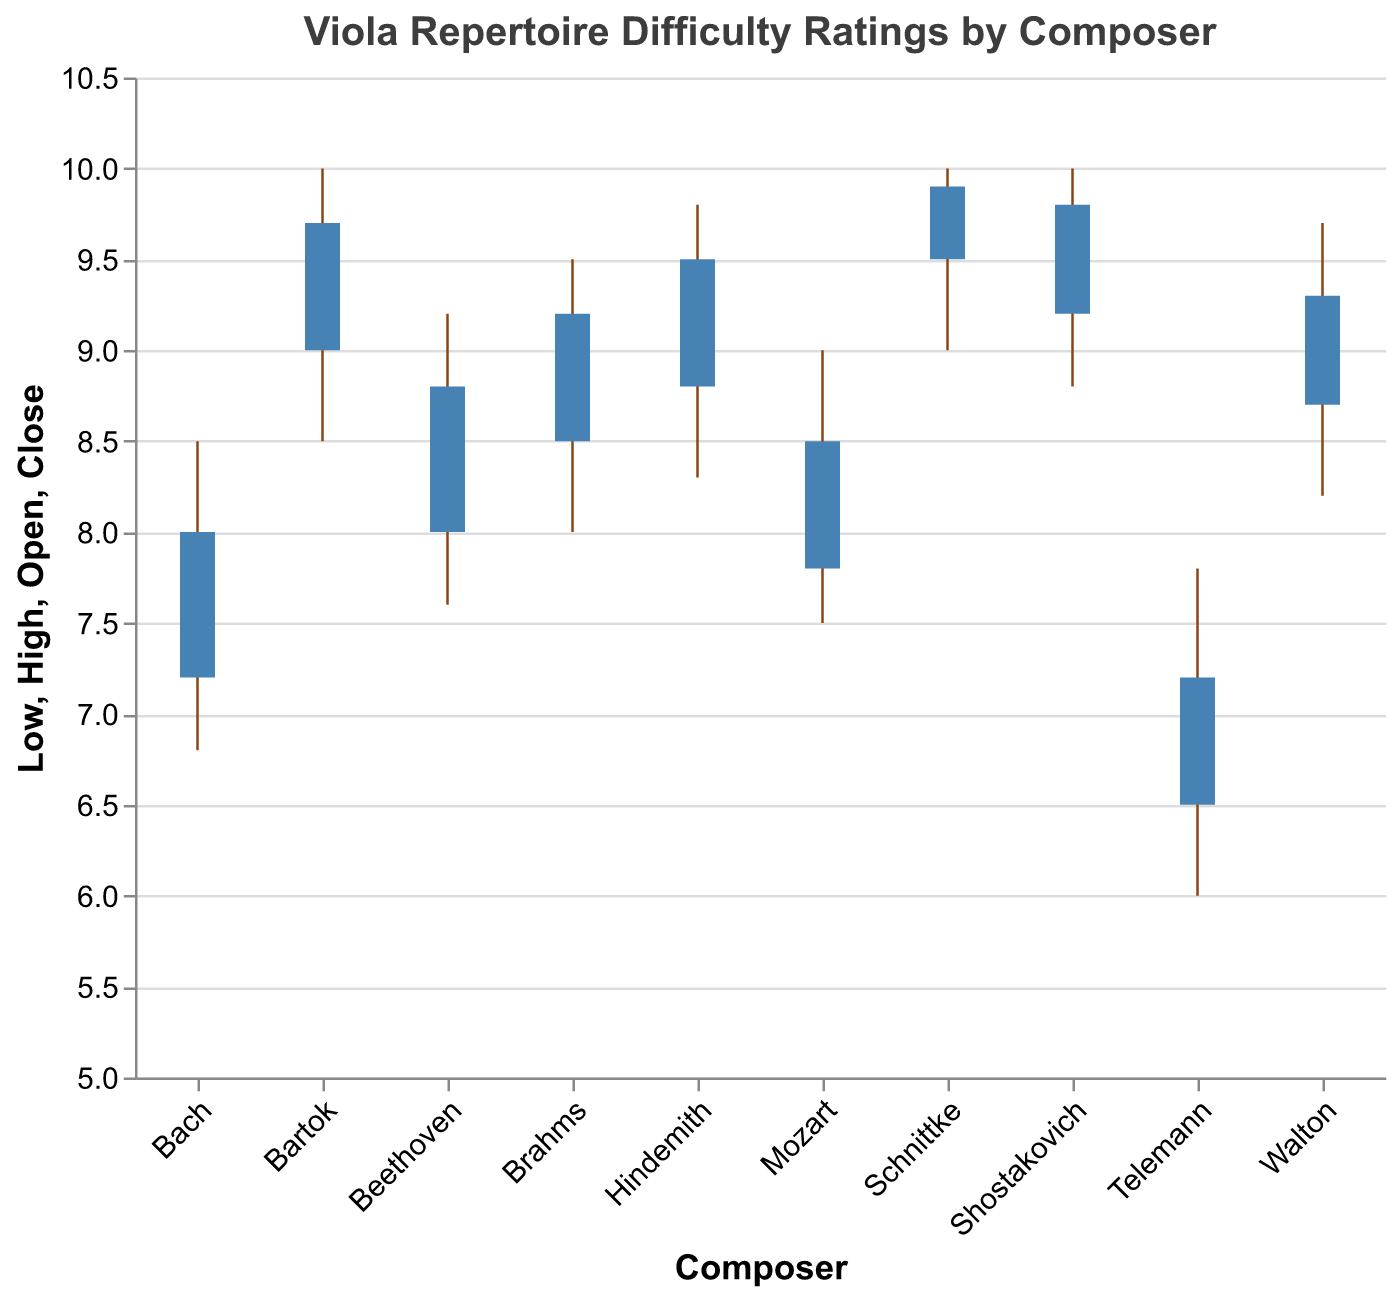what is the high (maximum) difficulty rating for Shostakovich's compositions? The high difficulty rating for Shostakovich’s compositions is labeled as 10 in the figure. This is the highest value on the upper axis of the OHLC chart bar for Shostakovich.
Answer: 10 What is the range of difficulty values for Telemann's compositions? For Telemann, the range of difficulty values is calculated by subtracting the lowest value (6.0) from the highest value (7.8). So the range is 7.8 - 6 = 1.8.
Answer: 1.8 Which composer has the largest difference between the open and close difficulty ratings? To find the composer with the largest difference between the open and close scores, look at the height difference of the bars. Schnittke has the largest difference, with values 9.9 (Close) and 9.5 (Open), a difference of 0.4.
Answer: Schnittke What is Brahms's close difficulty rating? Brahms's close difficulty rating is indicated at 9.2 in the figure, shown at the end of the bar representing Brahms’s compositions.
Answer: 9.2 Compare the average 'High' difficulty rating of Bach and Beethoven. Which one is higher and by how much? The average 'High' difficulty rating for each composer is given in the figure. For Bach, it is 8.5, and for Beethoven, it is 9.2. The difference is 9.2 - 8.5 = 0.7. Therefore, Beethoven's average 'High' difficulty rating is higher by 0.7.
Answer: Beethoven by 0.7 Which composers have compositions with a 'High' difficulty rating of 10? By checking the 'High' values in the figure, Bartok, Shostakovich, and Schnittke all have compositions with a 'High' difficulty rating of 10.
Answer: Bartok, Shostakovich, and Schnittke Out of the listed composers, who has the lowest 'Low' difficulty rating? The figure shows that Telemann has a 'Low' difficulty rating of 6.0, which is the lowest among the listed composers.
Answer: Telemann Estimate the average 'Open' difficulty rating for all composers. To estimate the average 'Open' rating, sum all the 'Open' values and divide by the number of composers: (7.2 + 6.5 + 7.8 + 8.0 + 8.5 + 8.8 + 9.0 + 8.7 + 9.2 + 9.5) / 10 = 8.32.
Answer: 8.32 